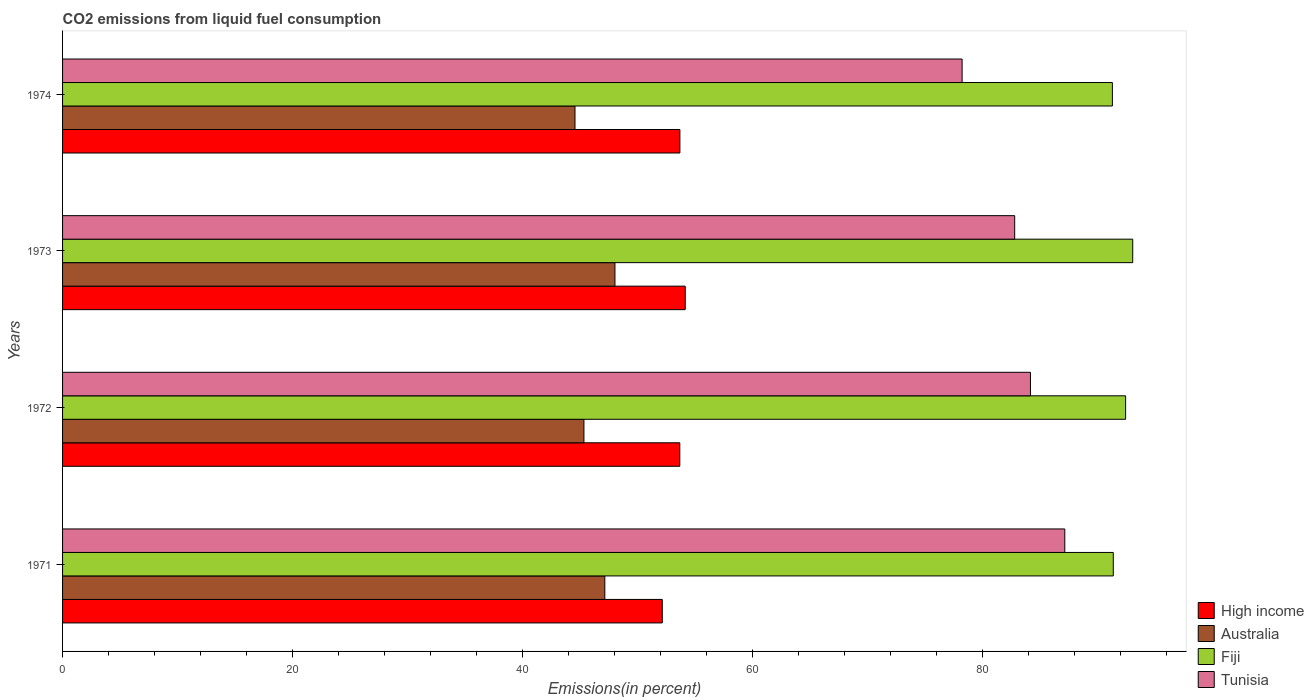How many different coloured bars are there?
Offer a very short reply. 4. How many groups of bars are there?
Offer a very short reply. 4. Are the number of bars per tick equal to the number of legend labels?
Make the answer very short. Yes. How many bars are there on the 2nd tick from the top?
Ensure brevity in your answer.  4. How many bars are there on the 3rd tick from the bottom?
Offer a terse response. 4. What is the label of the 4th group of bars from the top?
Your answer should be very brief. 1971. What is the total CO2 emitted in Australia in 1971?
Provide a short and direct response. 47.14. Across all years, what is the maximum total CO2 emitted in Fiji?
Ensure brevity in your answer.  93.02. Across all years, what is the minimum total CO2 emitted in Australia?
Your response must be concise. 44.54. In which year was the total CO2 emitted in Fiji maximum?
Make the answer very short. 1973. What is the total total CO2 emitted in High income in the graph?
Offer a terse response. 213.57. What is the difference between the total CO2 emitted in Fiji in 1971 and that in 1974?
Your answer should be compact. 0.08. What is the difference between the total CO2 emitted in Tunisia in 1973 and the total CO2 emitted in High income in 1974?
Your answer should be very brief. 29.1. What is the average total CO2 emitted in High income per year?
Give a very brief answer. 53.39. In the year 1972, what is the difference between the total CO2 emitted in Tunisia and total CO2 emitted in Fiji?
Provide a short and direct response. -8.27. What is the ratio of the total CO2 emitted in Tunisia in 1973 to that in 1974?
Give a very brief answer. 1.06. Is the difference between the total CO2 emitted in Tunisia in 1971 and 1974 greater than the difference between the total CO2 emitted in Fiji in 1971 and 1974?
Your answer should be compact. Yes. What is the difference between the highest and the second highest total CO2 emitted in High income?
Your response must be concise. 0.46. What is the difference between the highest and the lowest total CO2 emitted in High income?
Your answer should be compact. 1.99. In how many years, is the total CO2 emitted in Tunisia greater than the average total CO2 emitted in Tunisia taken over all years?
Ensure brevity in your answer.  2. Is the sum of the total CO2 emitted in Tunisia in 1971 and 1972 greater than the maximum total CO2 emitted in High income across all years?
Provide a succinct answer. Yes. Is it the case that in every year, the sum of the total CO2 emitted in Tunisia and total CO2 emitted in Fiji is greater than the sum of total CO2 emitted in Australia and total CO2 emitted in High income?
Offer a terse response. No. What does the 2nd bar from the top in 1974 represents?
Offer a very short reply. Fiji. What does the 2nd bar from the bottom in 1971 represents?
Provide a succinct answer. Australia. Are all the bars in the graph horizontal?
Your answer should be compact. Yes. How many years are there in the graph?
Ensure brevity in your answer.  4. What is the difference between two consecutive major ticks on the X-axis?
Keep it short and to the point. 20. Does the graph contain any zero values?
Your response must be concise. No. Does the graph contain grids?
Offer a terse response. No. Where does the legend appear in the graph?
Your response must be concise. Bottom right. How many legend labels are there?
Your answer should be very brief. 4. How are the legend labels stacked?
Your answer should be compact. Vertical. What is the title of the graph?
Offer a very short reply. CO2 emissions from liquid fuel consumption. What is the label or title of the X-axis?
Provide a succinct answer. Emissions(in percent). What is the label or title of the Y-axis?
Provide a short and direct response. Years. What is the Emissions(in percent) in High income in 1971?
Your answer should be compact. 52.13. What is the Emissions(in percent) of Australia in 1971?
Your answer should be very brief. 47.14. What is the Emissions(in percent) in Fiji in 1971?
Provide a succinct answer. 91.33. What is the Emissions(in percent) in Tunisia in 1971?
Your answer should be very brief. 87.12. What is the Emissions(in percent) in High income in 1972?
Offer a very short reply. 53.65. What is the Emissions(in percent) of Australia in 1972?
Offer a terse response. 45.32. What is the Emissions(in percent) in Fiji in 1972?
Ensure brevity in your answer.  92.41. What is the Emissions(in percent) in Tunisia in 1972?
Offer a terse response. 84.13. What is the Emissions(in percent) in High income in 1973?
Offer a terse response. 54.13. What is the Emissions(in percent) in Australia in 1973?
Your answer should be very brief. 48.02. What is the Emissions(in percent) in Fiji in 1973?
Offer a terse response. 93.02. What is the Emissions(in percent) of Tunisia in 1973?
Your answer should be very brief. 82.76. What is the Emissions(in percent) of High income in 1974?
Provide a short and direct response. 53.66. What is the Emissions(in percent) in Australia in 1974?
Give a very brief answer. 44.54. What is the Emissions(in percent) of Fiji in 1974?
Your answer should be very brief. 91.26. What is the Emissions(in percent) in Tunisia in 1974?
Ensure brevity in your answer.  78.19. Across all years, what is the maximum Emissions(in percent) of High income?
Offer a very short reply. 54.13. Across all years, what is the maximum Emissions(in percent) of Australia?
Offer a terse response. 48.02. Across all years, what is the maximum Emissions(in percent) of Fiji?
Provide a succinct answer. 93.02. Across all years, what is the maximum Emissions(in percent) in Tunisia?
Your answer should be very brief. 87.12. Across all years, what is the minimum Emissions(in percent) in High income?
Keep it short and to the point. 52.13. Across all years, what is the minimum Emissions(in percent) in Australia?
Your answer should be very brief. 44.54. Across all years, what is the minimum Emissions(in percent) in Fiji?
Keep it short and to the point. 91.26. Across all years, what is the minimum Emissions(in percent) in Tunisia?
Offer a very short reply. 78.19. What is the total Emissions(in percent) of High income in the graph?
Offer a very short reply. 213.57. What is the total Emissions(in percent) of Australia in the graph?
Your answer should be very brief. 185.02. What is the total Emissions(in percent) of Fiji in the graph?
Give a very brief answer. 368.02. What is the total Emissions(in percent) in Tunisia in the graph?
Offer a terse response. 332.21. What is the difference between the Emissions(in percent) of High income in 1971 and that in 1972?
Keep it short and to the point. -1.52. What is the difference between the Emissions(in percent) of Australia in 1971 and that in 1972?
Offer a terse response. 1.82. What is the difference between the Emissions(in percent) in Fiji in 1971 and that in 1972?
Make the answer very short. -1.07. What is the difference between the Emissions(in percent) of Tunisia in 1971 and that in 1972?
Keep it short and to the point. 2.99. What is the difference between the Emissions(in percent) of High income in 1971 and that in 1973?
Give a very brief answer. -1.99. What is the difference between the Emissions(in percent) in Australia in 1971 and that in 1973?
Your answer should be very brief. -0.88. What is the difference between the Emissions(in percent) in Fiji in 1971 and that in 1973?
Offer a very short reply. -1.69. What is the difference between the Emissions(in percent) in Tunisia in 1971 and that in 1973?
Provide a short and direct response. 4.36. What is the difference between the Emissions(in percent) of High income in 1971 and that in 1974?
Ensure brevity in your answer.  -1.53. What is the difference between the Emissions(in percent) of Australia in 1971 and that in 1974?
Your answer should be very brief. 2.59. What is the difference between the Emissions(in percent) of Fiji in 1971 and that in 1974?
Offer a very short reply. 0.08. What is the difference between the Emissions(in percent) in Tunisia in 1971 and that in 1974?
Provide a short and direct response. 8.93. What is the difference between the Emissions(in percent) of High income in 1972 and that in 1973?
Offer a terse response. -0.47. What is the difference between the Emissions(in percent) of Australia in 1972 and that in 1973?
Make the answer very short. -2.7. What is the difference between the Emissions(in percent) in Fiji in 1972 and that in 1973?
Offer a very short reply. -0.62. What is the difference between the Emissions(in percent) in Tunisia in 1972 and that in 1973?
Ensure brevity in your answer.  1.37. What is the difference between the Emissions(in percent) of High income in 1972 and that in 1974?
Your answer should be very brief. -0.01. What is the difference between the Emissions(in percent) of Australia in 1972 and that in 1974?
Ensure brevity in your answer.  0.78. What is the difference between the Emissions(in percent) in Fiji in 1972 and that in 1974?
Provide a succinct answer. 1.15. What is the difference between the Emissions(in percent) of Tunisia in 1972 and that in 1974?
Ensure brevity in your answer.  5.94. What is the difference between the Emissions(in percent) in High income in 1973 and that in 1974?
Offer a terse response. 0.46. What is the difference between the Emissions(in percent) in Australia in 1973 and that in 1974?
Provide a succinct answer. 3.47. What is the difference between the Emissions(in percent) in Fiji in 1973 and that in 1974?
Make the answer very short. 1.77. What is the difference between the Emissions(in percent) in Tunisia in 1973 and that in 1974?
Ensure brevity in your answer.  4.57. What is the difference between the Emissions(in percent) in High income in 1971 and the Emissions(in percent) in Australia in 1972?
Your answer should be very brief. 6.81. What is the difference between the Emissions(in percent) in High income in 1971 and the Emissions(in percent) in Fiji in 1972?
Ensure brevity in your answer.  -40.27. What is the difference between the Emissions(in percent) of High income in 1971 and the Emissions(in percent) of Tunisia in 1972?
Your response must be concise. -32. What is the difference between the Emissions(in percent) of Australia in 1971 and the Emissions(in percent) of Fiji in 1972?
Make the answer very short. -45.27. What is the difference between the Emissions(in percent) of Australia in 1971 and the Emissions(in percent) of Tunisia in 1972?
Keep it short and to the point. -37. What is the difference between the Emissions(in percent) of Fiji in 1971 and the Emissions(in percent) of Tunisia in 1972?
Make the answer very short. 7.2. What is the difference between the Emissions(in percent) in High income in 1971 and the Emissions(in percent) in Australia in 1973?
Your response must be concise. 4.11. What is the difference between the Emissions(in percent) in High income in 1971 and the Emissions(in percent) in Fiji in 1973?
Your answer should be compact. -40.89. What is the difference between the Emissions(in percent) in High income in 1971 and the Emissions(in percent) in Tunisia in 1973?
Give a very brief answer. -30.63. What is the difference between the Emissions(in percent) of Australia in 1971 and the Emissions(in percent) of Fiji in 1973?
Offer a very short reply. -45.89. What is the difference between the Emissions(in percent) of Australia in 1971 and the Emissions(in percent) of Tunisia in 1973?
Provide a short and direct response. -35.63. What is the difference between the Emissions(in percent) in Fiji in 1971 and the Emissions(in percent) in Tunisia in 1973?
Your answer should be very brief. 8.57. What is the difference between the Emissions(in percent) of High income in 1971 and the Emissions(in percent) of Australia in 1974?
Offer a very short reply. 7.59. What is the difference between the Emissions(in percent) in High income in 1971 and the Emissions(in percent) in Fiji in 1974?
Ensure brevity in your answer.  -39.13. What is the difference between the Emissions(in percent) of High income in 1971 and the Emissions(in percent) of Tunisia in 1974?
Provide a short and direct response. -26.06. What is the difference between the Emissions(in percent) in Australia in 1971 and the Emissions(in percent) in Fiji in 1974?
Keep it short and to the point. -44.12. What is the difference between the Emissions(in percent) in Australia in 1971 and the Emissions(in percent) in Tunisia in 1974?
Offer a very short reply. -31.06. What is the difference between the Emissions(in percent) in Fiji in 1971 and the Emissions(in percent) in Tunisia in 1974?
Make the answer very short. 13.14. What is the difference between the Emissions(in percent) in High income in 1972 and the Emissions(in percent) in Australia in 1973?
Give a very brief answer. 5.64. What is the difference between the Emissions(in percent) in High income in 1972 and the Emissions(in percent) in Fiji in 1973?
Offer a terse response. -39.37. What is the difference between the Emissions(in percent) in High income in 1972 and the Emissions(in percent) in Tunisia in 1973?
Your answer should be compact. -29.11. What is the difference between the Emissions(in percent) of Australia in 1972 and the Emissions(in percent) of Fiji in 1973?
Provide a short and direct response. -47.7. What is the difference between the Emissions(in percent) in Australia in 1972 and the Emissions(in percent) in Tunisia in 1973?
Your answer should be very brief. -37.44. What is the difference between the Emissions(in percent) in Fiji in 1972 and the Emissions(in percent) in Tunisia in 1973?
Provide a succinct answer. 9.64. What is the difference between the Emissions(in percent) of High income in 1972 and the Emissions(in percent) of Australia in 1974?
Provide a succinct answer. 9.11. What is the difference between the Emissions(in percent) of High income in 1972 and the Emissions(in percent) of Fiji in 1974?
Provide a succinct answer. -37.6. What is the difference between the Emissions(in percent) in High income in 1972 and the Emissions(in percent) in Tunisia in 1974?
Provide a short and direct response. -24.54. What is the difference between the Emissions(in percent) of Australia in 1972 and the Emissions(in percent) of Fiji in 1974?
Your answer should be compact. -45.94. What is the difference between the Emissions(in percent) in Australia in 1972 and the Emissions(in percent) in Tunisia in 1974?
Make the answer very short. -32.87. What is the difference between the Emissions(in percent) in Fiji in 1972 and the Emissions(in percent) in Tunisia in 1974?
Give a very brief answer. 14.21. What is the difference between the Emissions(in percent) in High income in 1973 and the Emissions(in percent) in Australia in 1974?
Offer a terse response. 9.58. What is the difference between the Emissions(in percent) of High income in 1973 and the Emissions(in percent) of Fiji in 1974?
Offer a terse response. -37.13. What is the difference between the Emissions(in percent) of High income in 1973 and the Emissions(in percent) of Tunisia in 1974?
Make the answer very short. -24.07. What is the difference between the Emissions(in percent) in Australia in 1973 and the Emissions(in percent) in Fiji in 1974?
Provide a succinct answer. -43.24. What is the difference between the Emissions(in percent) of Australia in 1973 and the Emissions(in percent) of Tunisia in 1974?
Keep it short and to the point. -30.18. What is the difference between the Emissions(in percent) of Fiji in 1973 and the Emissions(in percent) of Tunisia in 1974?
Offer a terse response. 14.83. What is the average Emissions(in percent) in High income per year?
Your response must be concise. 53.39. What is the average Emissions(in percent) of Australia per year?
Keep it short and to the point. 46.25. What is the average Emissions(in percent) in Fiji per year?
Ensure brevity in your answer.  92. What is the average Emissions(in percent) of Tunisia per year?
Provide a short and direct response. 83.05. In the year 1971, what is the difference between the Emissions(in percent) of High income and Emissions(in percent) of Australia?
Ensure brevity in your answer.  4.99. In the year 1971, what is the difference between the Emissions(in percent) of High income and Emissions(in percent) of Fiji?
Keep it short and to the point. -39.2. In the year 1971, what is the difference between the Emissions(in percent) of High income and Emissions(in percent) of Tunisia?
Offer a terse response. -34.99. In the year 1971, what is the difference between the Emissions(in percent) of Australia and Emissions(in percent) of Fiji?
Ensure brevity in your answer.  -44.2. In the year 1971, what is the difference between the Emissions(in percent) of Australia and Emissions(in percent) of Tunisia?
Your response must be concise. -39.98. In the year 1971, what is the difference between the Emissions(in percent) in Fiji and Emissions(in percent) in Tunisia?
Your answer should be very brief. 4.21. In the year 1972, what is the difference between the Emissions(in percent) of High income and Emissions(in percent) of Australia?
Provide a short and direct response. 8.33. In the year 1972, what is the difference between the Emissions(in percent) of High income and Emissions(in percent) of Fiji?
Your response must be concise. -38.75. In the year 1972, what is the difference between the Emissions(in percent) of High income and Emissions(in percent) of Tunisia?
Provide a short and direct response. -30.48. In the year 1972, what is the difference between the Emissions(in percent) in Australia and Emissions(in percent) in Fiji?
Keep it short and to the point. -47.08. In the year 1972, what is the difference between the Emissions(in percent) of Australia and Emissions(in percent) of Tunisia?
Your answer should be very brief. -38.81. In the year 1972, what is the difference between the Emissions(in percent) in Fiji and Emissions(in percent) in Tunisia?
Keep it short and to the point. 8.27. In the year 1973, what is the difference between the Emissions(in percent) of High income and Emissions(in percent) of Australia?
Provide a succinct answer. 6.11. In the year 1973, what is the difference between the Emissions(in percent) in High income and Emissions(in percent) in Fiji?
Provide a short and direct response. -38.9. In the year 1973, what is the difference between the Emissions(in percent) in High income and Emissions(in percent) in Tunisia?
Make the answer very short. -28.64. In the year 1973, what is the difference between the Emissions(in percent) of Australia and Emissions(in percent) of Fiji?
Provide a succinct answer. -45.01. In the year 1973, what is the difference between the Emissions(in percent) in Australia and Emissions(in percent) in Tunisia?
Your answer should be very brief. -34.75. In the year 1973, what is the difference between the Emissions(in percent) in Fiji and Emissions(in percent) in Tunisia?
Give a very brief answer. 10.26. In the year 1974, what is the difference between the Emissions(in percent) of High income and Emissions(in percent) of Australia?
Provide a short and direct response. 9.12. In the year 1974, what is the difference between the Emissions(in percent) of High income and Emissions(in percent) of Fiji?
Ensure brevity in your answer.  -37.6. In the year 1974, what is the difference between the Emissions(in percent) in High income and Emissions(in percent) in Tunisia?
Make the answer very short. -24.53. In the year 1974, what is the difference between the Emissions(in percent) of Australia and Emissions(in percent) of Fiji?
Your answer should be very brief. -46.71. In the year 1974, what is the difference between the Emissions(in percent) of Australia and Emissions(in percent) of Tunisia?
Offer a very short reply. -33.65. In the year 1974, what is the difference between the Emissions(in percent) of Fiji and Emissions(in percent) of Tunisia?
Your answer should be compact. 13.06. What is the ratio of the Emissions(in percent) in High income in 1971 to that in 1972?
Offer a very short reply. 0.97. What is the ratio of the Emissions(in percent) in Australia in 1971 to that in 1972?
Keep it short and to the point. 1.04. What is the ratio of the Emissions(in percent) in Fiji in 1971 to that in 1972?
Ensure brevity in your answer.  0.99. What is the ratio of the Emissions(in percent) in Tunisia in 1971 to that in 1972?
Your answer should be very brief. 1.04. What is the ratio of the Emissions(in percent) of High income in 1971 to that in 1973?
Your answer should be compact. 0.96. What is the ratio of the Emissions(in percent) in Australia in 1971 to that in 1973?
Ensure brevity in your answer.  0.98. What is the ratio of the Emissions(in percent) in Fiji in 1971 to that in 1973?
Keep it short and to the point. 0.98. What is the ratio of the Emissions(in percent) in Tunisia in 1971 to that in 1973?
Provide a succinct answer. 1.05. What is the ratio of the Emissions(in percent) in High income in 1971 to that in 1974?
Offer a terse response. 0.97. What is the ratio of the Emissions(in percent) of Australia in 1971 to that in 1974?
Give a very brief answer. 1.06. What is the ratio of the Emissions(in percent) in Fiji in 1971 to that in 1974?
Your answer should be very brief. 1. What is the ratio of the Emissions(in percent) in Tunisia in 1971 to that in 1974?
Provide a short and direct response. 1.11. What is the ratio of the Emissions(in percent) of High income in 1972 to that in 1973?
Offer a terse response. 0.99. What is the ratio of the Emissions(in percent) in Australia in 1972 to that in 1973?
Offer a very short reply. 0.94. What is the ratio of the Emissions(in percent) of Fiji in 1972 to that in 1973?
Your answer should be compact. 0.99. What is the ratio of the Emissions(in percent) in Tunisia in 1972 to that in 1973?
Offer a terse response. 1.02. What is the ratio of the Emissions(in percent) of High income in 1972 to that in 1974?
Your answer should be very brief. 1. What is the ratio of the Emissions(in percent) in Australia in 1972 to that in 1974?
Your answer should be very brief. 1.02. What is the ratio of the Emissions(in percent) of Fiji in 1972 to that in 1974?
Keep it short and to the point. 1.01. What is the ratio of the Emissions(in percent) of Tunisia in 1972 to that in 1974?
Ensure brevity in your answer.  1.08. What is the ratio of the Emissions(in percent) of High income in 1973 to that in 1974?
Give a very brief answer. 1.01. What is the ratio of the Emissions(in percent) in Australia in 1973 to that in 1974?
Make the answer very short. 1.08. What is the ratio of the Emissions(in percent) in Fiji in 1973 to that in 1974?
Provide a succinct answer. 1.02. What is the ratio of the Emissions(in percent) in Tunisia in 1973 to that in 1974?
Keep it short and to the point. 1.06. What is the difference between the highest and the second highest Emissions(in percent) of High income?
Offer a terse response. 0.46. What is the difference between the highest and the second highest Emissions(in percent) in Australia?
Ensure brevity in your answer.  0.88. What is the difference between the highest and the second highest Emissions(in percent) in Fiji?
Keep it short and to the point. 0.62. What is the difference between the highest and the second highest Emissions(in percent) in Tunisia?
Your answer should be very brief. 2.99. What is the difference between the highest and the lowest Emissions(in percent) of High income?
Your answer should be very brief. 1.99. What is the difference between the highest and the lowest Emissions(in percent) of Australia?
Ensure brevity in your answer.  3.47. What is the difference between the highest and the lowest Emissions(in percent) of Fiji?
Make the answer very short. 1.77. What is the difference between the highest and the lowest Emissions(in percent) of Tunisia?
Your answer should be compact. 8.93. 